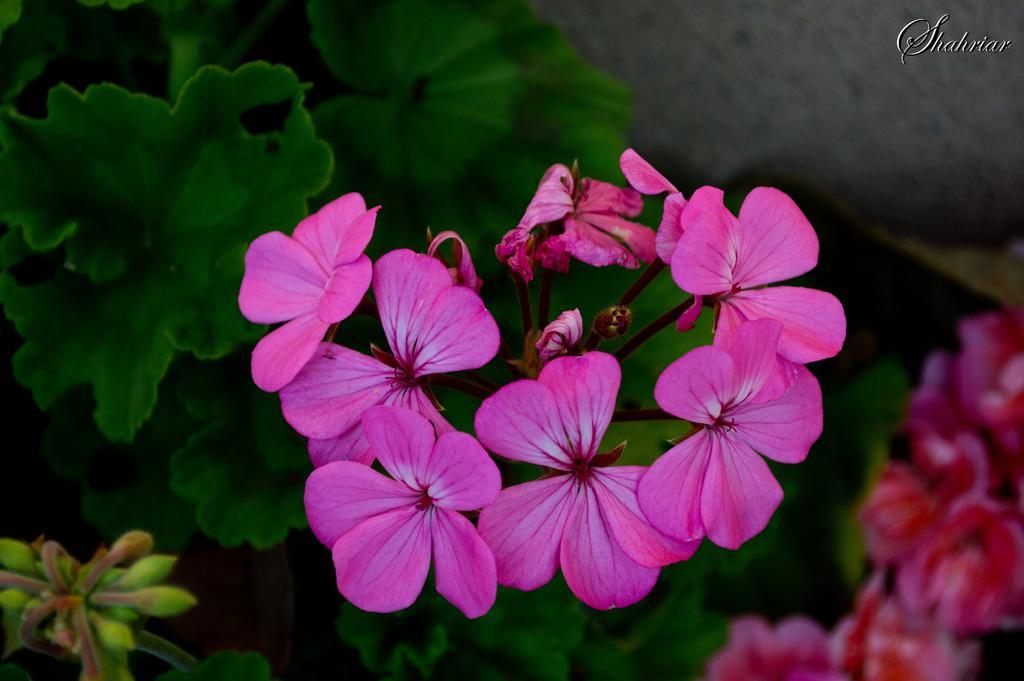Could you give a brief overview of what you see in this image? In this image there are buds in the left corner. There are flowers and some text in the right in the right corner. There are pink colored flowers in the foreground. And there are leaves in the background. 